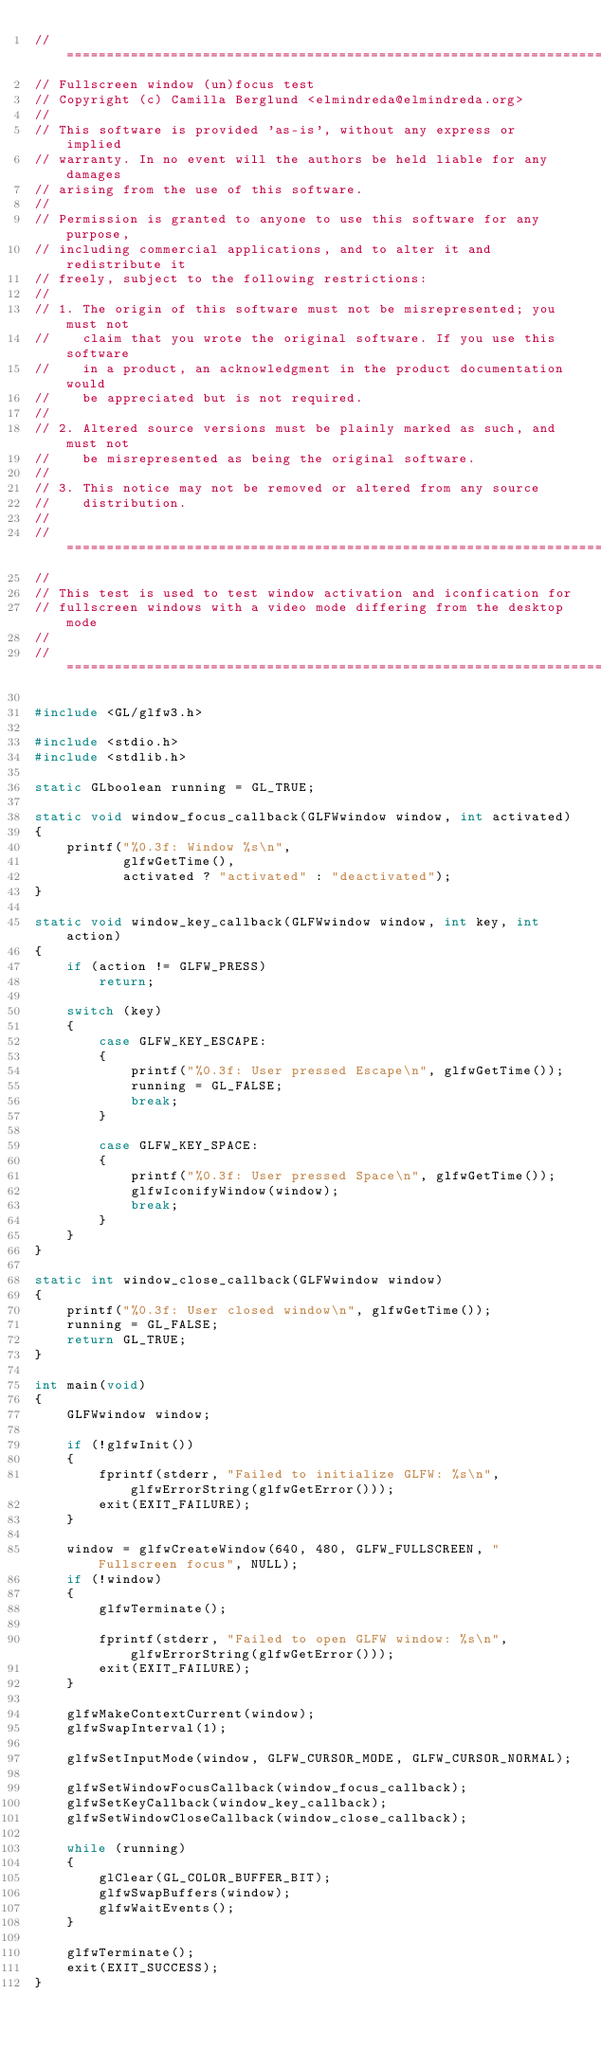<code> <loc_0><loc_0><loc_500><loc_500><_C_>//========================================================================
// Fullscreen window (un)focus test
// Copyright (c) Camilla Berglund <elmindreda@elmindreda.org>
//
// This software is provided 'as-is', without any express or implied
// warranty. In no event will the authors be held liable for any damages
// arising from the use of this software.
//
// Permission is granted to anyone to use this software for any purpose,
// including commercial applications, and to alter it and redistribute it
// freely, subject to the following restrictions:
//
// 1. The origin of this software must not be misrepresented; you must not
//    claim that you wrote the original software. If you use this software
//    in a product, an acknowledgment in the product documentation would
//    be appreciated but is not required.
//
// 2. Altered source versions must be plainly marked as such, and must not
//    be misrepresented as being the original software.
//
// 3. This notice may not be removed or altered from any source
//    distribution.
//
//========================================================================
//
// This test is used to test window activation and iconfication for
// fullscreen windows with a video mode differing from the desktop mode
//
//========================================================================

#include <GL/glfw3.h>

#include <stdio.h>
#include <stdlib.h>

static GLboolean running = GL_TRUE;

static void window_focus_callback(GLFWwindow window, int activated)
{
    printf("%0.3f: Window %s\n",
           glfwGetTime(),
           activated ? "activated" : "deactivated");
}

static void window_key_callback(GLFWwindow window, int key, int action)
{
    if (action != GLFW_PRESS)
        return;

    switch (key)
    {
        case GLFW_KEY_ESCAPE:
        {
            printf("%0.3f: User pressed Escape\n", glfwGetTime());
            running = GL_FALSE;
            break;
        }

        case GLFW_KEY_SPACE:
        {
            printf("%0.3f: User pressed Space\n", glfwGetTime());
            glfwIconifyWindow(window);
            break;
        }
    }
}

static int window_close_callback(GLFWwindow window)
{
    printf("%0.3f: User closed window\n", glfwGetTime());
    running = GL_FALSE;
    return GL_TRUE;
}

int main(void)
{
    GLFWwindow window;

    if (!glfwInit())
    {
        fprintf(stderr, "Failed to initialize GLFW: %s\n", glfwErrorString(glfwGetError()));
        exit(EXIT_FAILURE);
    }

    window = glfwCreateWindow(640, 480, GLFW_FULLSCREEN, "Fullscreen focus", NULL);
    if (!window)
    {
        glfwTerminate();

        fprintf(stderr, "Failed to open GLFW window: %s\n", glfwErrorString(glfwGetError()));
        exit(EXIT_FAILURE);
    }

    glfwMakeContextCurrent(window);
    glfwSwapInterval(1);

    glfwSetInputMode(window, GLFW_CURSOR_MODE, GLFW_CURSOR_NORMAL);

    glfwSetWindowFocusCallback(window_focus_callback);
    glfwSetKeyCallback(window_key_callback);
    glfwSetWindowCloseCallback(window_close_callback);

    while (running)
    {
        glClear(GL_COLOR_BUFFER_BIT);
        glfwSwapBuffers(window);
        glfwWaitEvents();
    }

    glfwTerminate();
    exit(EXIT_SUCCESS);
}

</code> 